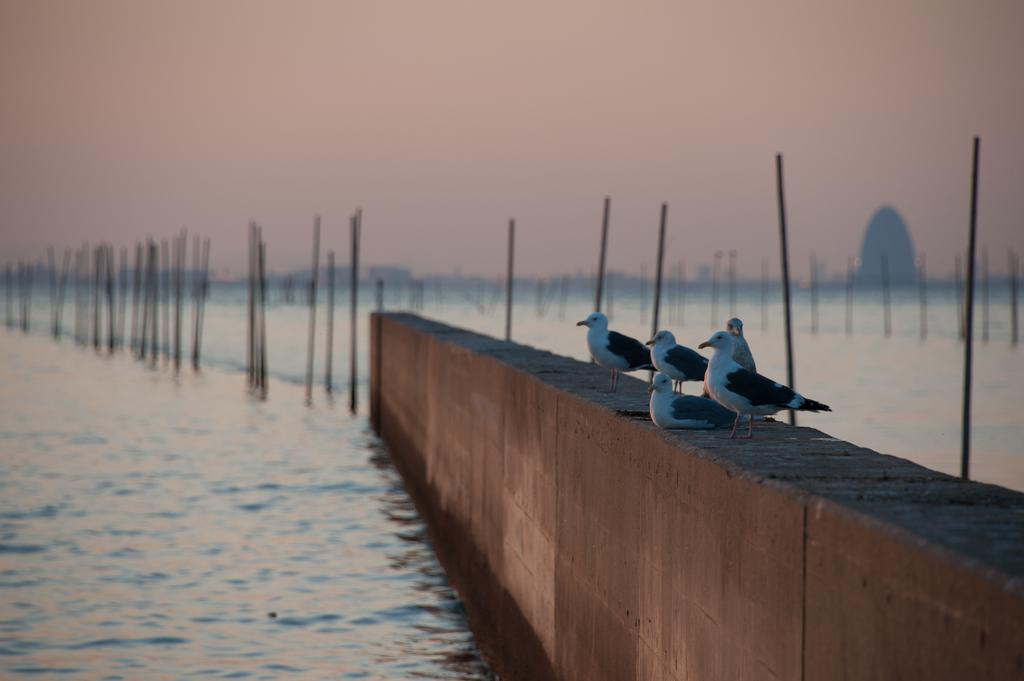What is present on the wall in the image? There are birds on the wall in the image. What else can be seen in the image besides the wall and birds? There are poles and water visible in the image. What is visible in the background of the image? The sky is visible in the background of the image. What type of vest can be seen on the birds in the image? There is no vest present in the image. The image features birds on a wall, poles, water, and a visible sky in the background. 